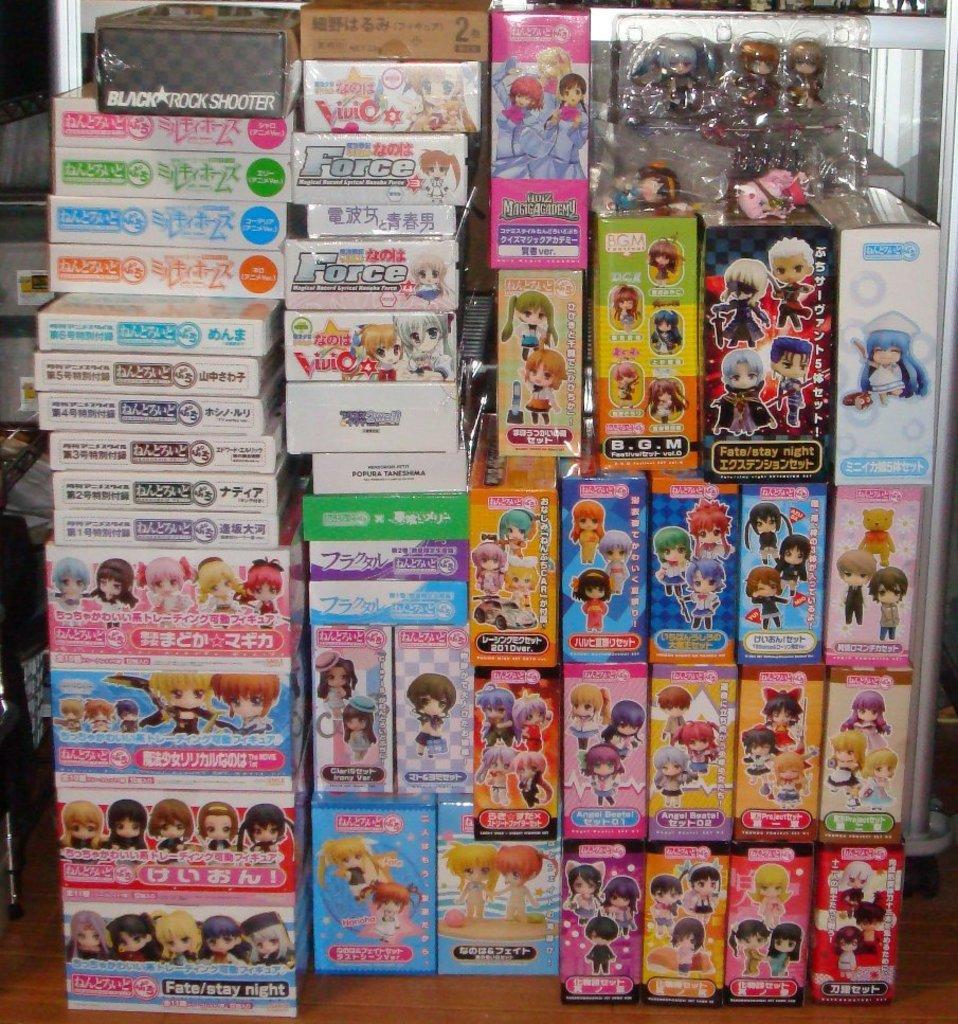Describe this image in one or two sentences. In this picture I can see toy stock boxes. 